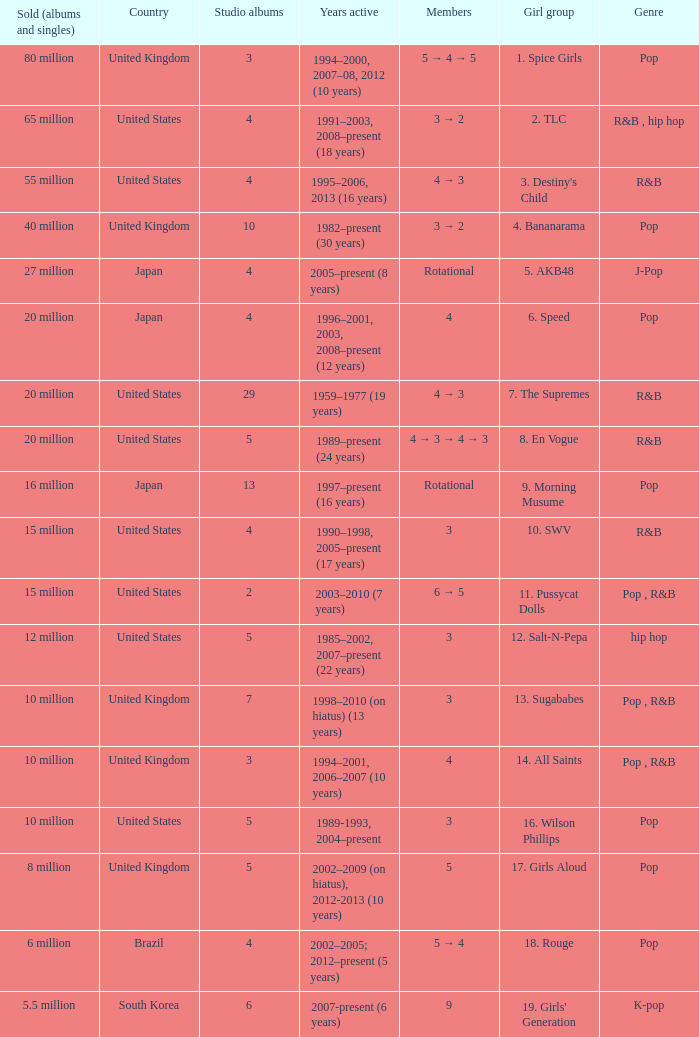What group had 29 studio albums? 7. The Supremes. 